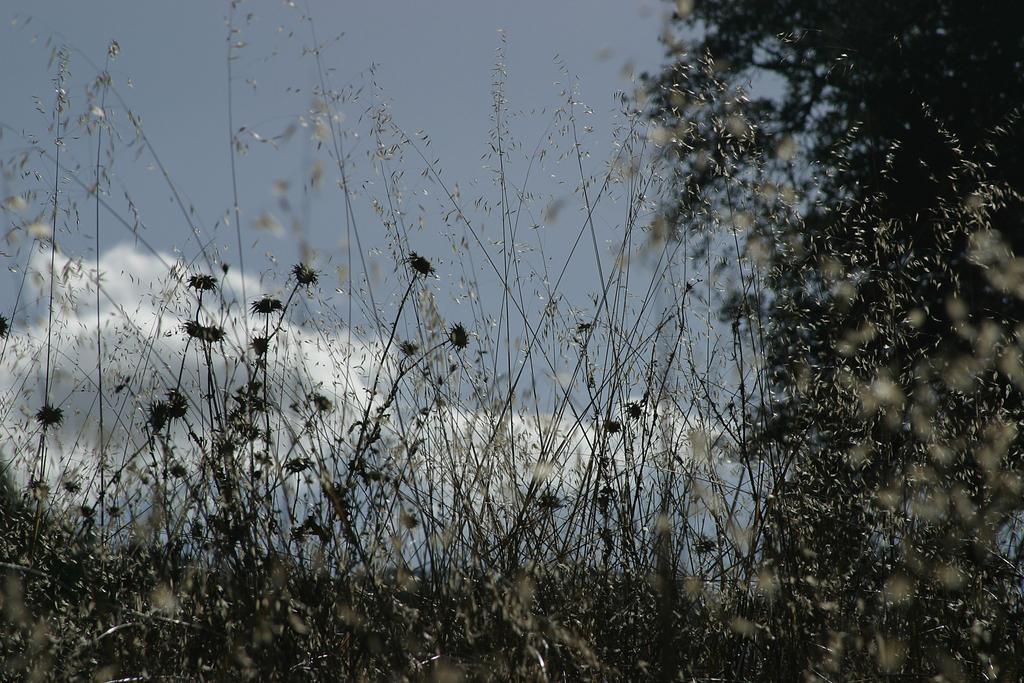What type of vegetation can be seen in the image? There are plants and flowers in the image. What other plant is visible in the image? There is a tree in the image. What can be seen in the background of the image? The sky is visible in the background of the image. What is the condition of the sky in the image? There are clouds in the sky. What type of straw is being used to decorate the flowers in the image? There is no straw present in the image; it features plants, flowers, and a tree. Can you see any bones in the image? There are no bones visible in the image. 